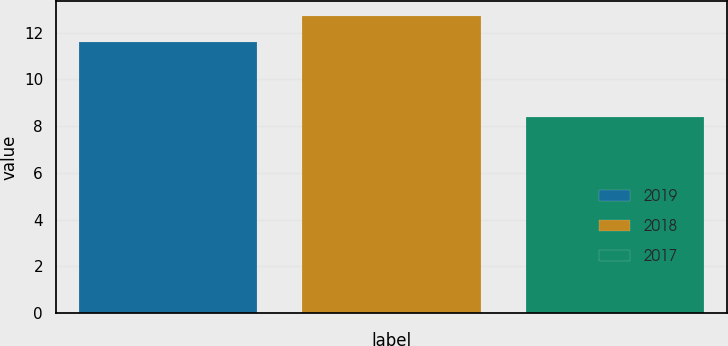Convert chart to OTSL. <chart><loc_0><loc_0><loc_500><loc_500><bar_chart><fcel>2019<fcel>2018<fcel>2017<nl><fcel>11.6<fcel>12.7<fcel>8.4<nl></chart> 